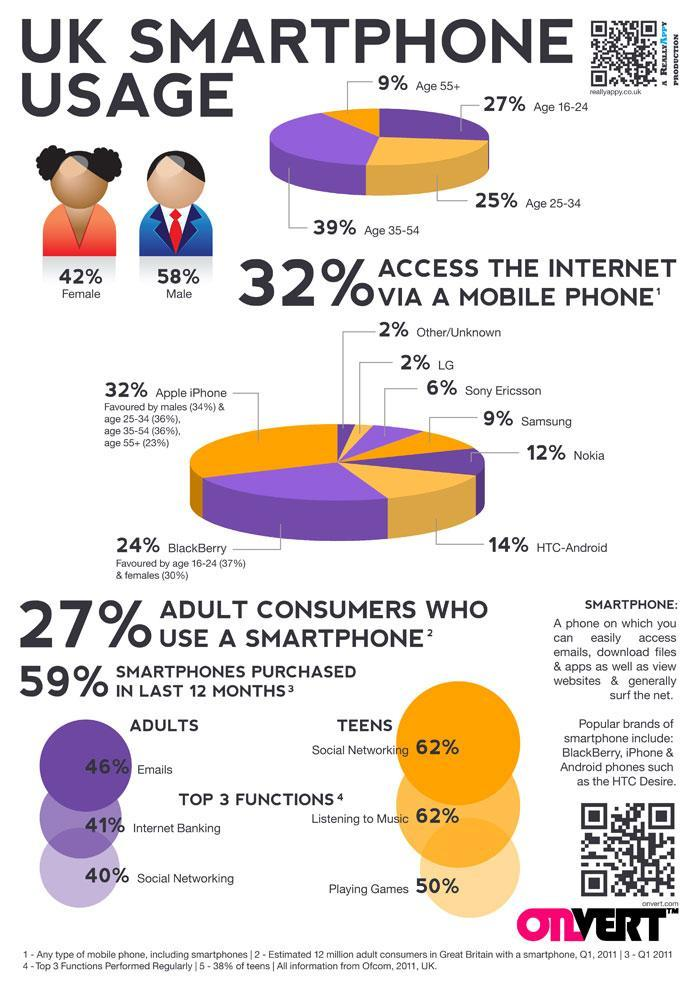What percent of people do not access internet via mobile phone?
Answer the question with a short phrase. 68% Among who is social networking most popular- adults or teens? TEENS What percent of senior citizens use Apple iPhone? 23% What percent of people in the age group 16-34 use smartphone? 52% What percent of senior citizens use smartphone in the UK? 9% Which is the second most preferred smartphone? Blackberry Which gender uses smartphone more? Male What percent of teenagers use smartphones for games? 50% What percent of people use Nokia, Samsung and Sony Ericsson? 27% 